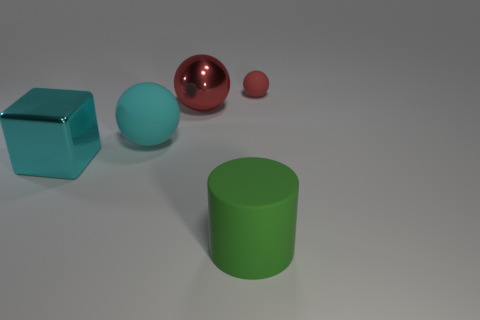Is there anything else that is the same size as the red rubber ball?
Your answer should be compact. No. Is the color of the big ball that is left of the red metallic ball the same as the small matte thing?
Give a very brief answer. No. Do the red ball on the right side of the matte cylinder and the red object on the left side of the cylinder have the same size?
Ensure brevity in your answer.  No. What is the size of the cyan object that is made of the same material as the cylinder?
Make the answer very short. Large. What number of things are both behind the cylinder and to the right of the large cyan cube?
Offer a terse response. 3. What number of objects are either big red spheres or rubber things behind the large red sphere?
Offer a very short reply. 2. What is the shape of the tiny thing that is the same color as the metal sphere?
Provide a succinct answer. Sphere. What color is the matte ball that is on the left side of the tiny red ball?
Provide a short and direct response. Cyan. What number of things are large matte objects on the left side of the big red ball or large cyan shiny cylinders?
Make the answer very short. 1. There is a cylinder that is the same size as the cyan ball; what color is it?
Keep it short and to the point. Green. 